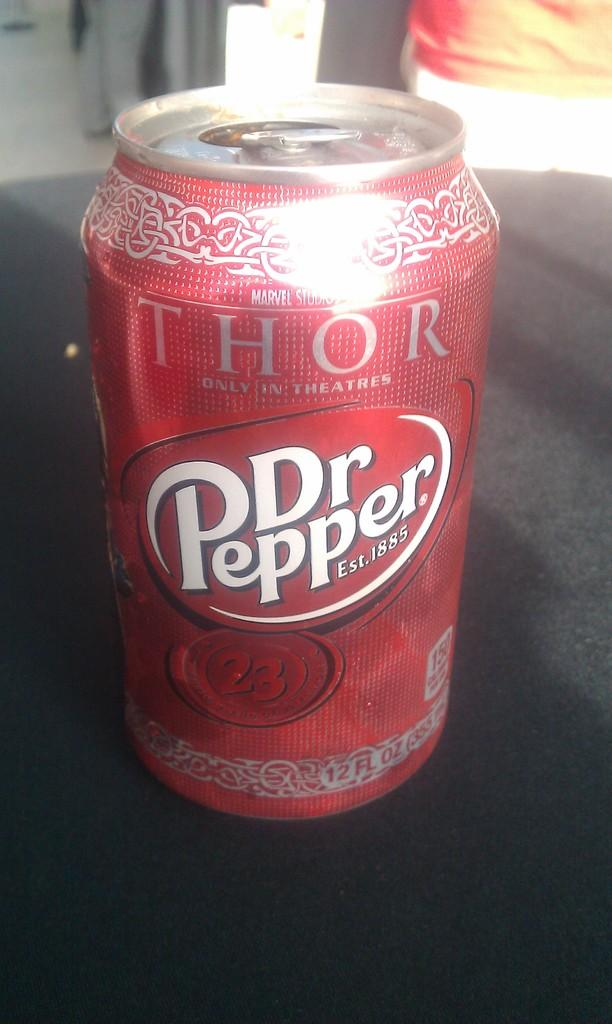<image>
Describe the image concisely. A can of Dr. Pepper has the name "THOR" at the top. 